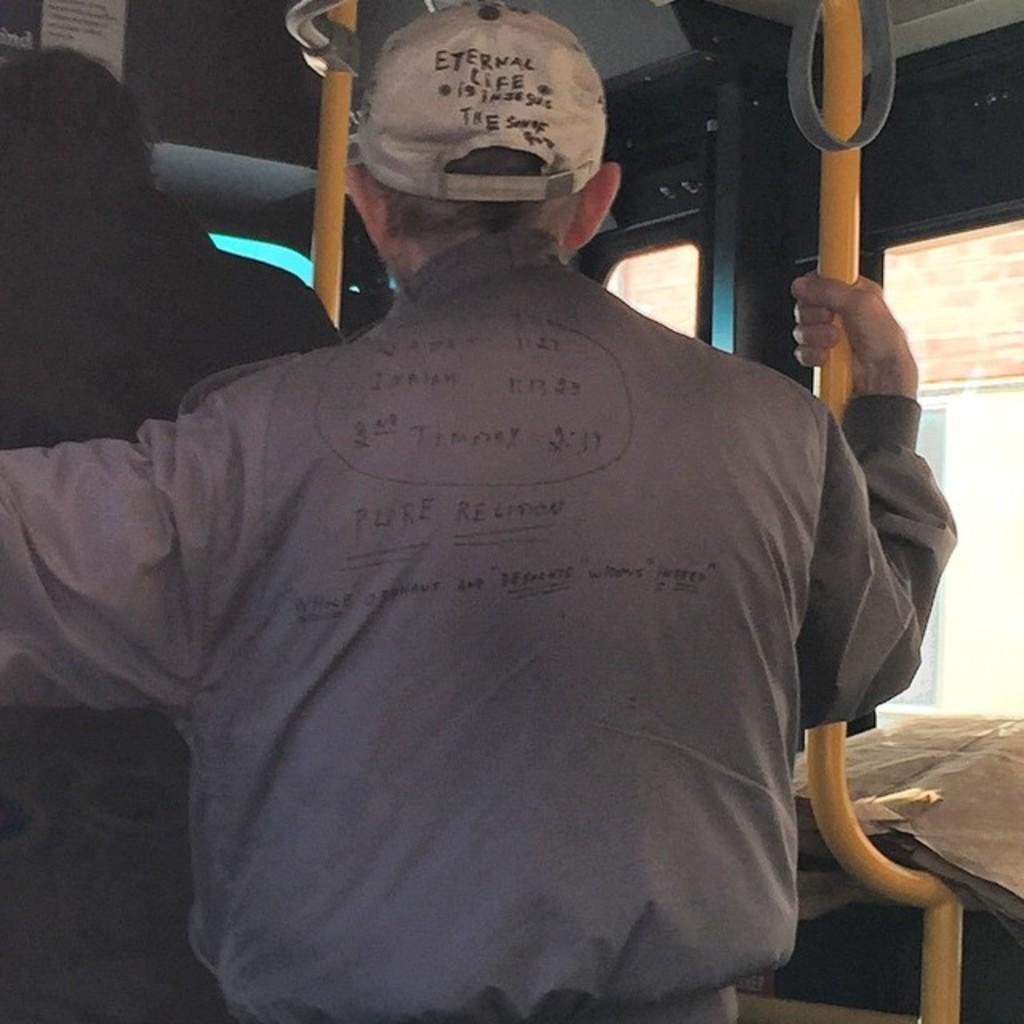How many people are present in the image? There are two people standing in the image. Where is the image taken? The image appears to be taken inside a vehicle. What can be seen outside the vehicle in the image? There are poles visible in the image. What separates the inside of the vehicle from the outside? There is a glass window in the image. What type of paste is being used by the people in the image? There is no paste visible or mentioned in the image. What type of room is the image taken in? The image is taken inside a vehicle, not a room. 